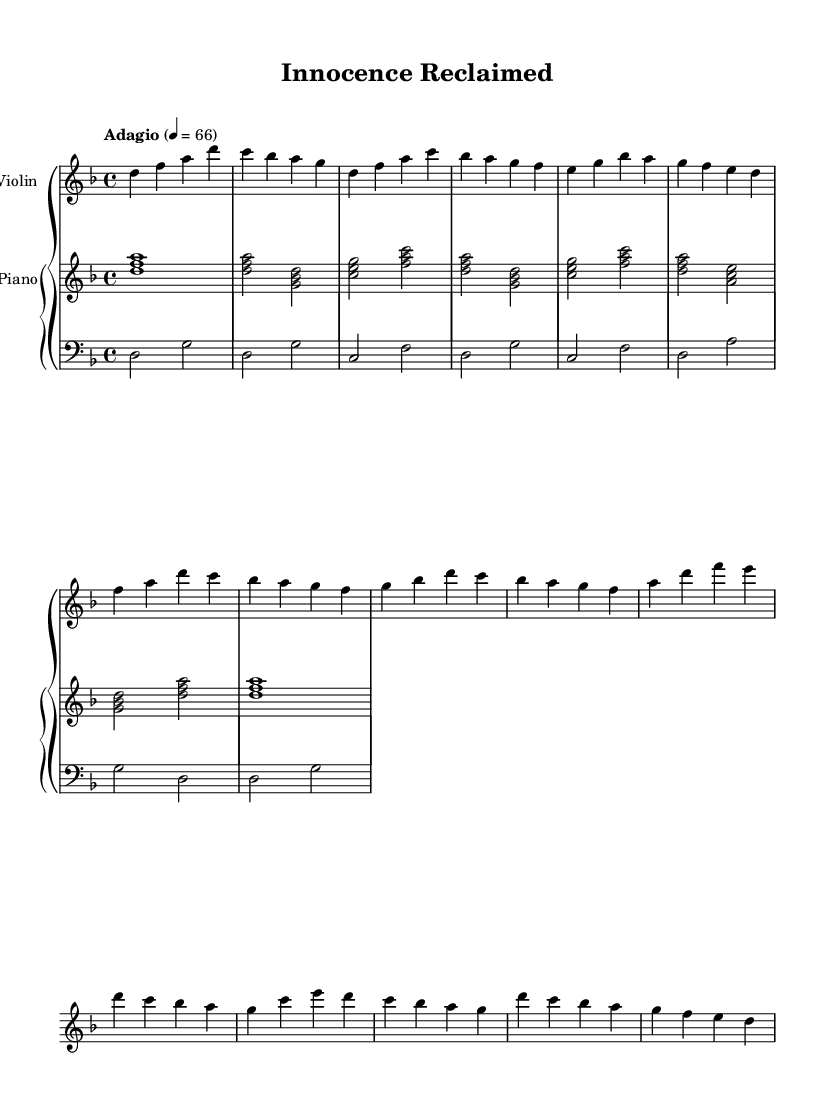What is the key signature of this music? The key signature indicated in the music is D minor, which has one flat (B flat).
Answer: D minor What is the time signature of the piece? The time signature shown in the music is 4/4, which means there are four beats in each measure and the quarter note gets one beat.
Answer: 4/4 What is the tempo marking for this piece? The tempo marking in the music indicates "Adagio," which implies a slow tempo, typically around 66 beats per minute.
Answer: Adagio How many measures are in the Intro section? The Intro section consists of one measure, indicated by the four note durations present before the next section begins.
Answer: 1 In which section does the first use of the chord "C E G" occur? The chord "C E G" first appears in the Verse 1 section, specifically in the second measure of that section, indicated by the corresponding notes written above.
Answer: Verse 1 What emotional theme does this music primarily explore? The music expresses themes of innocence and redemption, reflected in its melodic structure and harmonic choices, often associated with Romantic music.
Answer: Innocence and redemption How does the Bridge section introduce contrast compared to the Chorus? The Bridge section introduces new melodic motifs and harmonic progressions that create emotional depth, contrasting with the repetitive structure of the Chorus.
Answer: Contrast in melody 